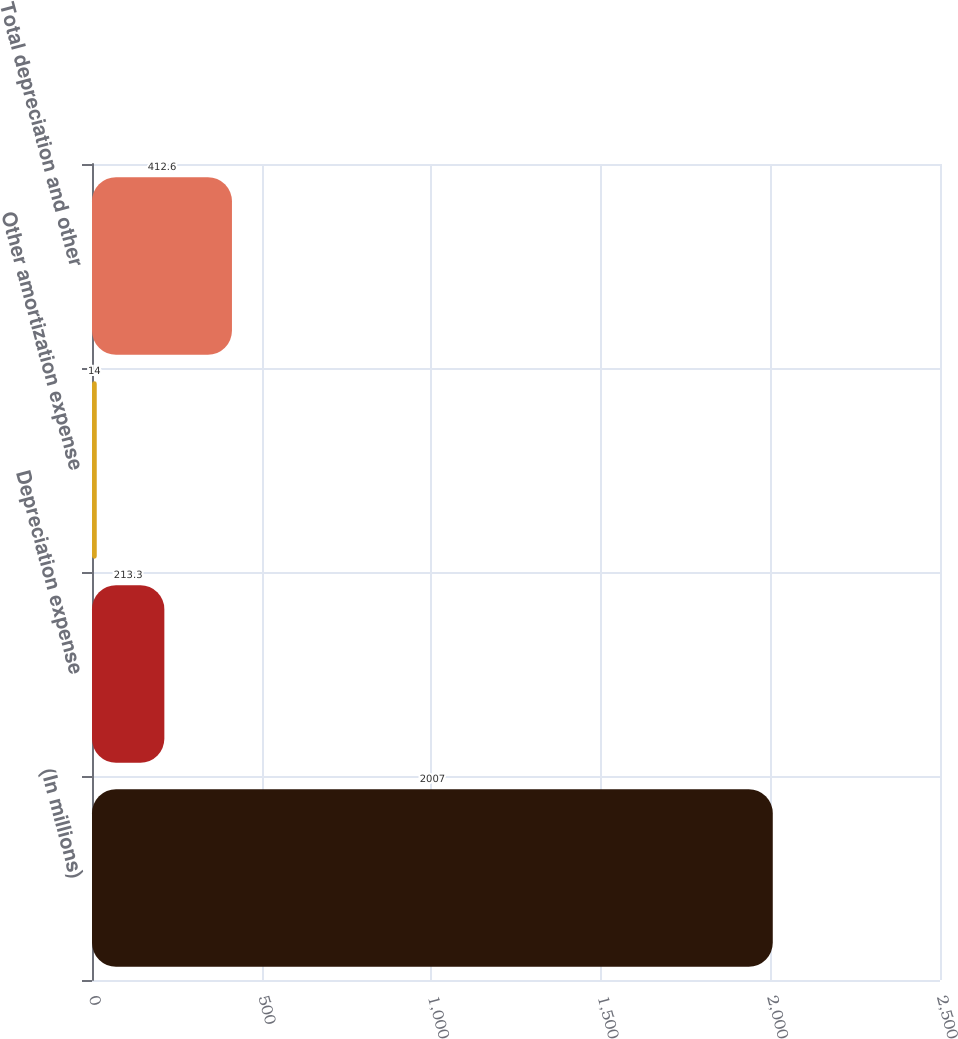Convert chart to OTSL. <chart><loc_0><loc_0><loc_500><loc_500><bar_chart><fcel>(In millions)<fcel>Depreciation expense<fcel>Other amortization expense<fcel>Total depreciation and other<nl><fcel>2007<fcel>213.3<fcel>14<fcel>412.6<nl></chart> 